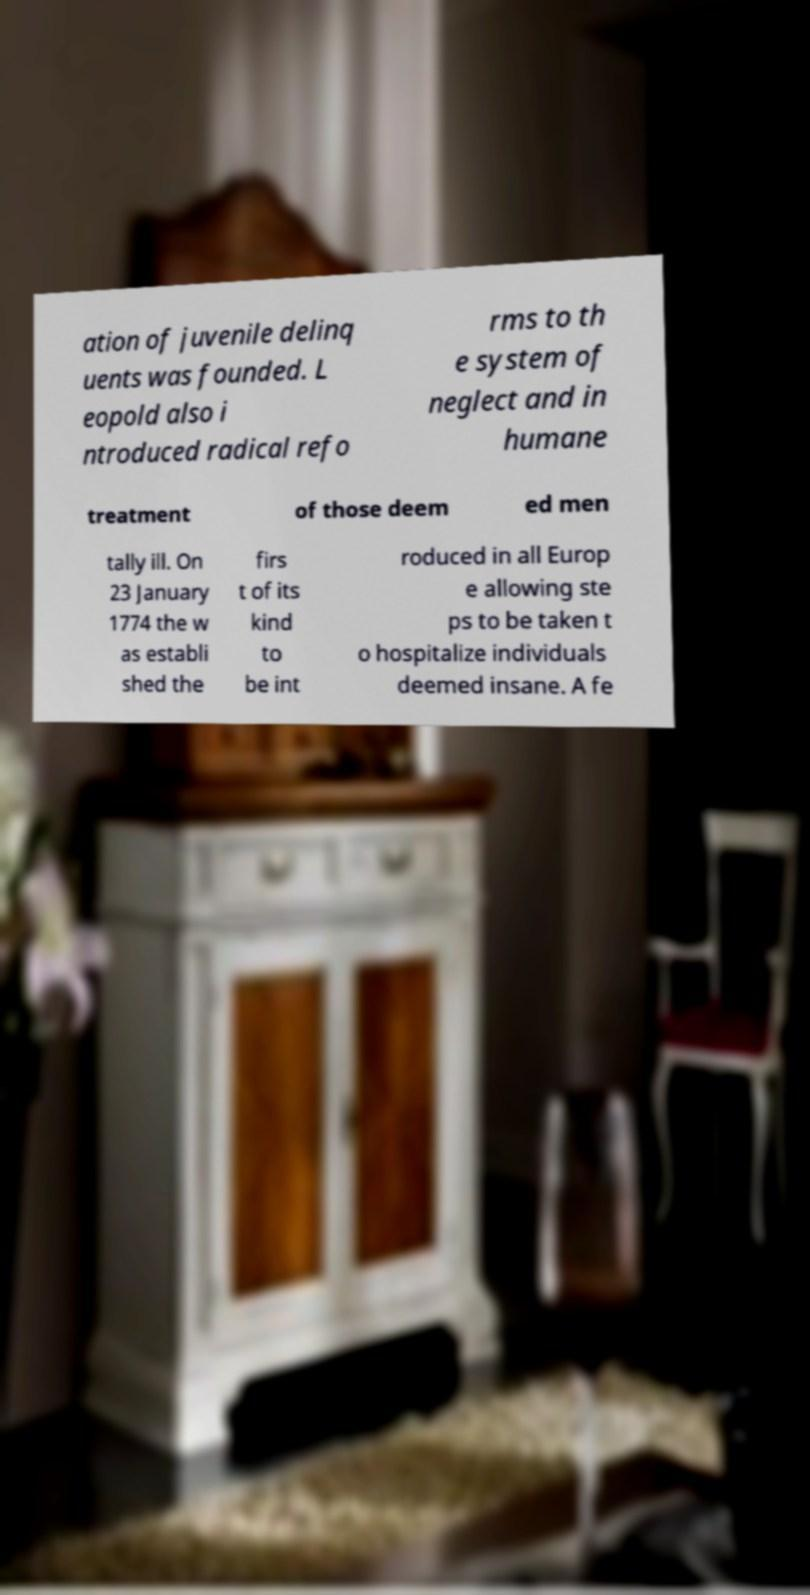Please read and relay the text visible in this image. What does it say? ation of juvenile delinq uents was founded. L eopold also i ntroduced radical refo rms to th e system of neglect and in humane treatment of those deem ed men tally ill. On 23 January 1774 the w as establi shed the firs t of its kind to be int roduced in all Europ e allowing ste ps to be taken t o hospitalize individuals deemed insane. A fe 